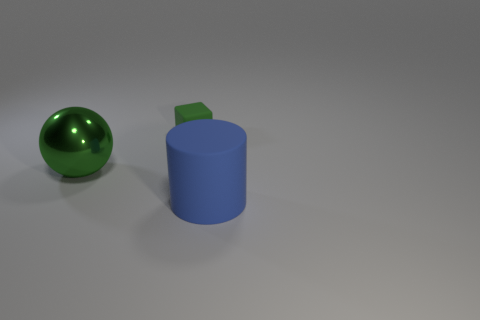Subtract all balls. How many objects are left? 2 Add 3 gray rubber blocks. How many objects exist? 6 Add 2 large objects. How many large objects are left? 4 Add 3 large shiny spheres. How many large shiny spheres exist? 4 Subtract 0 brown spheres. How many objects are left? 3 Subtract all brown metallic blocks. Subtract all big cylinders. How many objects are left? 2 